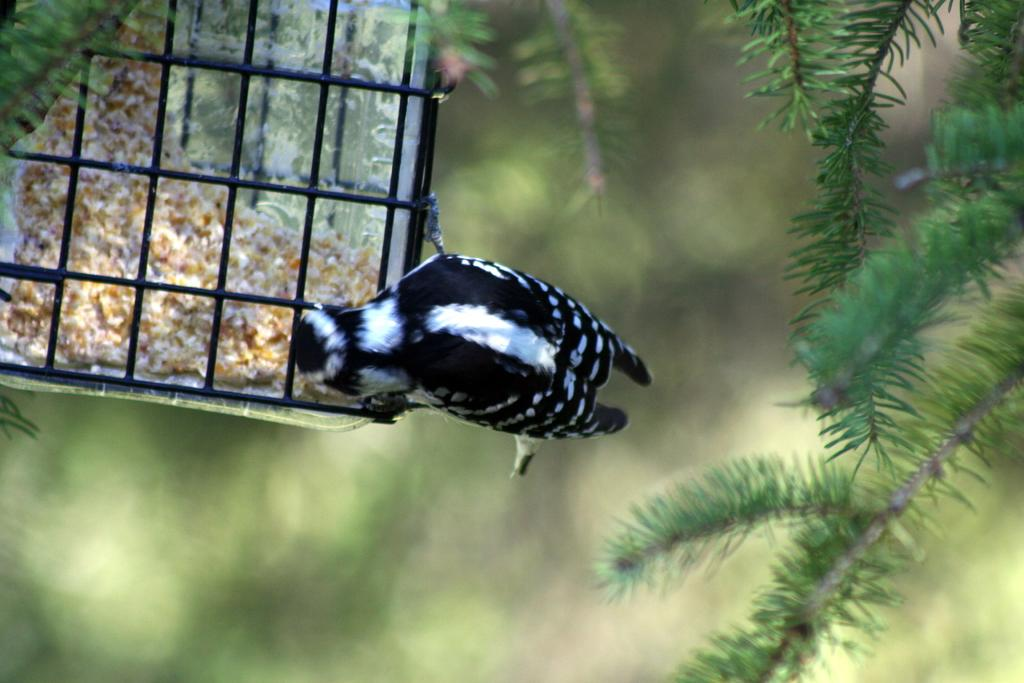What type of animal can be seen in the image? There is a bird in the image. What is the bird contained within? There is a cage in the image, and the bird is inside it. What is inside the cage with the bird? There is food inside the cage. What type of plant material is present in the image? There are leaves with stems in the image. How would you describe the background of the image? The background of the image is blurred and green in color. What type of business is being conducted in the image? There is no indication of a business in the image; it features a bird in a cage with food and leaves with stems. Is there a prison visible in the image? There is no prison present in the image; it features a bird in a cage with food and leaves with stems. 